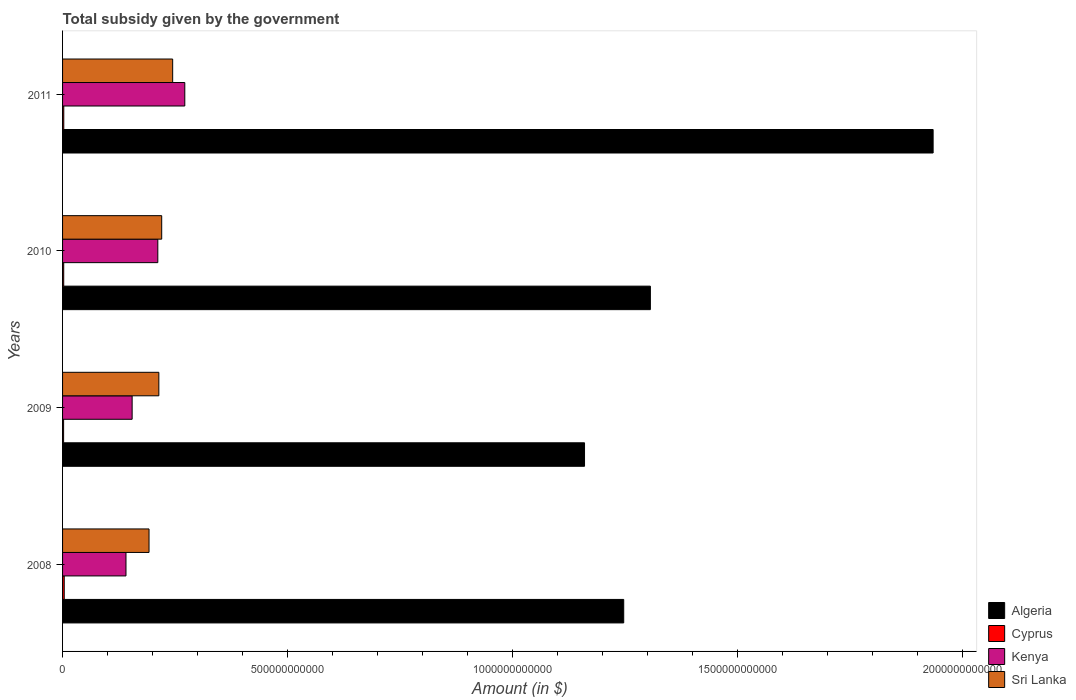Are the number of bars on each tick of the Y-axis equal?
Provide a succinct answer. Yes. How many bars are there on the 3rd tick from the top?
Your answer should be compact. 4. What is the label of the 2nd group of bars from the top?
Provide a short and direct response. 2010. In how many cases, is the number of bars for a given year not equal to the number of legend labels?
Your answer should be compact. 0. What is the total revenue collected by the government in Cyprus in 2008?
Your answer should be compact. 3.71e+09. Across all years, what is the maximum total revenue collected by the government in Algeria?
Offer a very short reply. 1.93e+12. Across all years, what is the minimum total revenue collected by the government in Sri Lanka?
Provide a succinct answer. 1.92e+11. In which year was the total revenue collected by the government in Sri Lanka maximum?
Offer a very short reply. 2011. In which year was the total revenue collected by the government in Algeria minimum?
Provide a succinct answer. 2009. What is the total total revenue collected by the government in Algeria in the graph?
Give a very brief answer. 5.65e+12. What is the difference between the total revenue collected by the government in Algeria in 2009 and that in 2010?
Give a very brief answer. -1.46e+11. What is the difference between the total revenue collected by the government in Kenya in 2009 and the total revenue collected by the government in Cyprus in 2011?
Your answer should be compact. 1.52e+11. What is the average total revenue collected by the government in Sri Lanka per year?
Keep it short and to the point. 2.18e+11. In the year 2008, what is the difference between the total revenue collected by the government in Sri Lanka and total revenue collected by the government in Cyprus?
Your answer should be very brief. 1.88e+11. What is the ratio of the total revenue collected by the government in Sri Lanka in 2010 to that in 2011?
Make the answer very short. 0.9. Is the total revenue collected by the government in Cyprus in 2010 less than that in 2011?
Offer a terse response. Yes. Is the difference between the total revenue collected by the government in Sri Lanka in 2009 and 2010 greater than the difference between the total revenue collected by the government in Cyprus in 2009 and 2010?
Make the answer very short. No. What is the difference between the highest and the second highest total revenue collected by the government in Algeria?
Provide a succinct answer. 6.28e+11. What is the difference between the highest and the lowest total revenue collected by the government in Sri Lanka?
Your answer should be very brief. 5.25e+1. In how many years, is the total revenue collected by the government in Sri Lanka greater than the average total revenue collected by the government in Sri Lanka taken over all years?
Give a very brief answer. 2. Is it the case that in every year, the sum of the total revenue collected by the government in Cyprus and total revenue collected by the government in Algeria is greater than the sum of total revenue collected by the government in Sri Lanka and total revenue collected by the government in Kenya?
Keep it short and to the point. Yes. What does the 3rd bar from the top in 2009 represents?
Provide a succinct answer. Cyprus. What does the 1st bar from the bottom in 2009 represents?
Your answer should be compact. Algeria. How many bars are there?
Keep it short and to the point. 16. Are all the bars in the graph horizontal?
Make the answer very short. Yes. What is the difference between two consecutive major ticks on the X-axis?
Make the answer very short. 5.00e+11. How many legend labels are there?
Provide a succinct answer. 4. What is the title of the graph?
Provide a succinct answer. Total subsidy given by the government. Does "St. Kitts and Nevis" appear as one of the legend labels in the graph?
Provide a short and direct response. No. What is the label or title of the X-axis?
Your answer should be very brief. Amount (in $). What is the label or title of the Y-axis?
Offer a very short reply. Years. What is the Amount (in $) in Algeria in 2008?
Offer a terse response. 1.25e+12. What is the Amount (in $) of Cyprus in 2008?
Provide a succinct answer. 3.71e+09. What is the Amount (in $) in Kenya in 2008?
Your answer should be very brief. 1.41e+11. What is the Amount (in $) of Sri Lanka in 2008?
Ensure brevity in your answer.  1.92e+11. What is the Amount (in $) in Algeria in 2009?
Ensure brevity in your answer.  1.16e+12. What is the Amount (in $) in Cyprus in 2009?
Provide a succinct answer. 2.31e+09. What is the Amount (in $) in Kenya in 2009?
Provide a succinct answer. 1.55e+11. What is the Amount (in $) in Sri Lanka in 2009?
Make the answer very short. 2.14e+11. What is the Amount (in $) of Algeria in 2010?
Offer a terse response. 1.31e+12. What is the Amount (in $) of Cyprus in 2010?
Offer a very short reply. 2.56e+09. What is the Amount (in $) of Kenya in 2010?
Your response must be concise. 2.12e+11. What is the Amount (in $) of Sri Lanka in 2010?
Provide a short and direct response. 2.20e+11. What is the Amount (in $) of Algeria in 2011?
Make the answer very short. 1.93e+12. What is the Amount (in $) of Cyprus in 2011?
Make the answer very short. 2.71e+09. What is the Amount (in $) of Kenya in 2011?
Keep it short and to the point. 2.72e+11. What is the Amount (in $) in Sri Lanka in 2011?
Ensure brevity in your answer.  2.45e+11. Across all years, what is the maximum Amount (in $) of Algeria?
Provide a short and direct response. 1.93e+12. Across all years, what is the maximum Amount (in $) of Cyprus?
Give a very brief answer. 3.71e+09. Across all years, what is the maximum Amount (in $) in Kenya?
Provide a short and direct response. 2.72e+11. Across all years, what is the maximum Amount (in $) in Sri Lanka?
Make the answer very short. 2.45e+11. Across all years, what is the minimum Amount (in $) of Algeria?
Offer a terse response. 1.16e+12. Across all years, what is the minimum Amount (in $) of Cyprus?
Your answer should be very brief. 2.31e+09. Across all years, what is the minimum Amount (in $) of Kenya?
Offer a terse response. 1.41e+11. Across all years, what is the minimum Amount (in $) in Sri Lanka?
Make the answer very short. 1.92e+11. What is the total Amount (in $) in Algeria in the graph?
Keep it short and to the point. 5.65e+12. What is the total Amount (in $) of Cyprus in the graph?
Provide a short and direct response. 1.13e+1. What is the total Amount (in $) of Kenya in the graph?
Make the answer very short. 7.79e+11. What is the total Amount (in $) of Sri Lanka in the graph?
Your response must be concise. 8.71e+11. What is the difference between the Amount (in $) of Algeria in 2008 and that in 2009?
Make the answer very short. 8.71e+1. What is the difference between the Amount (in $) in Cyprus in 2008 and that in 2009?
Provide a succinct answer. 1.40e+09. What is the difference between the Amount (in $) of Kenya in 2008 and that in 2009?
Provide a short and direct response. -1.37e+1. What is the difference between the Amount (in $) of Sri Lanka in 2008 and that in 2009?
Your response must be concise. -2.18e+1. What is the difference between the Amount (in $) in Algeria in 2008 and that in 2010?
Give a very brief answer. -5.92e+1. What is the difference between the Amount (in $) of Cyprus in 2008 and that in 2010?
Your response must be concise. 1.15e+09. What is the difference between the Amount (in $) of Kenya in 2008 and that in 2010?
Your answer should be compact. -7.07e+1. What is the difference between the Amount (in $) in Sri Lanka in 2008 and that in 2010?
Your answer should be very brief. -2.82e+1. What is the difference between the Amount (in $) in Algeria in 2008 and that in 2011?
Ensure brevity in your answer.  -6.88e+11. What is the difference between the Amount (in $) in Cyprus in 2008 and that in 2011?
Your answer should be compact. 9.95e+08. What is the difference between the Amount (in $) in Kenya in 2008 and that in 2011?
Give a very brief answer. -1.31e+11. What is the difference between the Amount (in $) in Sri Lanka in 2008 and that in 2011?
Offer a very short reply. -5.25e+1. What is the difference between the Amount (in $) in Algeria in 2009 and that in 2010?
Offer a very short reply. -1.46e+11. What is the difference between the Amount (in $) in Cyprus in 2009 and that in 2010?
Provide a succinct answer. -2.53e+08. What is the difference between the Amount (in $) of Kenya in 2009 and that in 2010?
Offer a terse response. -5.71e+1. What is the difference between the Amount (in $) of Sri Lanka in 2009 and that in 2010?
Ensure brevity in your answer.  -6.37e+09. What is the difference between the Amount (in $) in Algeria in 2009 and that in 2011?
Offer a very short reply. -7.75e+11. What is the difference between the Amount (in $) in Cyprus in 2009 and that in 2011?
Offer a very short reply. -4.07e+08. What is the difference between the Amount (in $) in Kenya in 2009 and that in 2011?
Your response must be concise. -1.17e+11. What is the difference between the Amount (in $) in Sri Lanka in 2009 and that in 2011?
Your response must be concise. -3.07e+1. What is the difference between the Amount (in $) in Algeria in 2010 and that in 2011?
Your answer should be compact. -6.28e+11. What is the difference between the Amount (in $) in Cyprus in 2010 and that in 2011?
Your answer should be very brief. -1.53e+08. What is the difference between the Amount (in $) of Kenya in 2010 and that in 2011?
Give a very brief answer. -6.00e+1. What is the difference between the Amount (in $) in Sri Lanka in 2010 and that in 2011?
Your answer should be compact. -2.44e+1. What is the difference between the Amount (in $) of Algeria in 2008 and the Amount (in $) of Cyprus in 2009?
Give a very brief answer. 1.24e+12. What is the difference between the Amount (in $) of Algeria in 2008 and the Amount (in $) of Kenya in 2009?
Provide a short and direct response. 1.09e+12. What is the difference between the Amount (in $) of Algeria in 2008 and the Amount (in $) of Sri Lanka in 2009?
Offer a terse response. 1.03e+12. What is the difference between the Amount (in $) in Cyprus in 2008 and the Amount (in $) in Kenya in 2009?
Your answer should be very brief. -1.51e+11. What is the difference between the Amount (in $) in Cyprus in 2008 and the Amount (in $) in Sri Lanka in 2009?
Provide a succinct answer. -2.10e+11. What is the difference between the Amount (in $) of Kenya in 2008 and the Amount (in $) of Sri Lanka in 2009?
Ensure brevity in your answer.  -7.30e+1. What is the difference between the Amount (in $) in Algeria in 2008 and the Amount (in $) in Cyprus in 2010?
Offer a terse response. 1.24e+12. What is the difference between the Amount (in $) of Algeria in 2008 and the Amount (in $) of Kenya in 2010?
Offer a terse response. 1.04e+12. What is the difference between the Amount (in $) of Algeria in 2008 and the Amount (in $) of Sri Lanka in 2010?
Your answer should be compact. 1.03e+12. What is the difference between the Amount (in $) of Cyprus in 2008 and the Amount (in $) of Kenya in 2010?
Offer a very short reply. -2.08e+11. What is the difference between the Amount (in $) of Cyprus in 2008 and the Amount (in $) of Sri Lanka in 2010?
Your answer should be compact. -2.17e+11. What is the difference between the Amount (in $) of Kenya in 2008 and the Amount (in $) of Sri Lanka in 2010?
Offer a very short reply. -7.94e+1. What is the difference between the Amount (in $) of Algeria in 2008 and the Amount (in $) of Cyprus in 2011?
Your response must be concise. 1.24e+12. What is the difference between the Amount (in $) in Algeria in 2008 and the Amount (in $) in Kenya in 2011?
Ensure brevity in your answer.  9.75e+11. What is the difference between the Amount (in $) of Algeria in 2008 and the Amount (in $) of Sri Lanka in 2011?
Provide a succinct answer. 1.00e+12. What is the difference between the Amount (in $) in Cyprus in 2008 and the Amount (in $) in Kenya in 2011?
Make the answer very short. -2.68e+11. What is the difference between the Amount (in $) in Cyprus in 2008 and the Amount (in $) in Sri Lanka in 2011?
Offer a very short reply. -2.41e+11. What is the difference between the Amount (in $) of Kenya in 2008 and the Amount (in $) of Sri Lanka in 2011?
Make the answer very short. -1.04e+11. What is the difference between the Amount (in $) in Algeria in 2009 and the Amount (in $) in Cyprus in 2010?
Provide a succinct answer. 1.16e+12. What is the difference between the Amount (in $) of Algeria in 2009 and the Amount (in $) of Kenya in 2010?
Provide a short and direct response. 9.48e+11. What is the difference between the Amount (in $) of Algeria in 2009 and the Amount (in $) of Sri Lanka in 2010?
Offer a terse response. 9.40e+11. What is the difference between the Amount (in $) of Cyprus in 2009 and the Amount (in $) of Kenya in 2010?
Keep it short and to the point. -2.09e+11. What is the difference between the Amount (in $) in Cyprus in 2009 and the Amount (in $) in Sri Lanka in 2010?
Make the answer very short. -2.18e+11. What is the difference between the Amount (in $) in Kenya in 2009 and the Amount (in $) in Sri Lanka in 2010?
Offer a very short reply. -6.57e+1. What is the difference between the Amount (in $) of Algeria in 2009 and the Amount (in $) of Cyprus in 2011?
Your response must be concise. 1.16e+12. What is the difference between the Amount (in $) of Algeria in 2009 and the Amount (in $) of Kenya in 2011?
Give a very brief answer. 8.88e+11. What is the difference between the Amount (in $) in Algeria in 2009 and the Amount (in $) in Sri Lanka in 2011?
Offer a very short reply. 9.15e+11. What is the difference between the Amount (in $) of Cyprus in 2009 and the Amount (in $) of Kenya in 2011?
Provide a short and direct response. -2.69e+11. What is the difference between the Amount (in $) of Cyprus in 2009 and the Amount (in $) of Sri Lanka in 2011?
Make the answer very short. -2.42e+11. What is the difference between the Amount (in $) in Kenya in 2009 and the Amount (in $) in Sri Lanka in 2011?
Provide a succinct answer. -9.01e+1. What is the difference between the Amount (in $) in Algeria in 2010 and the Amount (in $) in Cyprus in 2011?
Keep it short and to the point. 1.30e+12. What is the difference between the Amount (in $) of Algeria in 2010 and the Amount (in $) of Kenya in 2011?
Offer a terse response. 1.03e+12. What is the difference between the Amount (in $) in Algeria in 2010 and the Amount (in $) in Sri Lanka in 2011?
Your answer should be compact. 1.06e+12. What is the difference between the Amount (in $) of Cyprus in 2010 and the Amount (in $) of Kenya in 2011?
Provide a succinct answer. -2.69e+11. What is the difference between the Amount (in $) of Cyprus in 2010 and the Amount (in $) of Sri Lanka in 2011?
Your response must be concise. -2.42e+11. What is the difference between the Amount (in $) in Kenya in 2010 and the Amount (in $) in Sri Lanka in 2011?
Offer a terse response. -3.30e+1. What is the average Amount (in $) of Algeria per year?
Keep it short and to the point. 1.41e+12. What is the average Amount (in $) in Cyprus per year?
Give a very brief answer. 2.82e+09. What is the average Amount (in $) in Kenya per year?
Offer a terse response. 1.95e+11. What is the average Amount (in $) of Sri Lanka per year?
Your answer should be compact. 2.18e+11. In the year 2008, what is the difference between the Amount (in $) in Algeria and Amount (in $) in Cyprus?
Ensure brevity in your answer.  1.24e+12. In the year 2008, what is the difference between the Amount (in $) of Algeria and Amount (in $) of Kenya?
Give a very brief answer. 1.11e+12. In the year 2008, what is the difference between the Amount (in $) of Algeria and Amount (in $) of Sri Lanka?
Make the answer very short. 1.05e+12. In the year 2008, what is the difference between the Amount (in $) in Cyprus and Amount (in $) in Kenya?
Ensure brevity in your answer.  -1.37e+11. In the year 2008, what is the difference between the Amount (in $) in Cyprus and Amount (in $) in Sri Lanka?
Provide a short and direct response. -1.88e+11. In the year 2008, what is the difference between the Amount (in $) of Kenya and Amount (in $) of Sri Lanka?
Provide a succinct answer. -5.12e+1. In the year 2009, what is the difference between the Amount (in $) in Algeria and Amount (in $) in Cyprus?
Your response must be concise. 1.16e+12. In the year 2009, what is the difference between the Amount (in $) in Algeria and Amount (in $) in Kenya?
Ensure brevity in your answer.  1.01e+12. In the year 2009, what is the difference between the Amount (in $) in Algeria and Amount (in $) in Sri Lanka?
Provide a succinct answer. 9.46e+11. In the year 2009, what is the difference between the Amount (in $) in Cyprus and Amount (in $) in Kenya?
Make the answer very short. -1.52e+11. In the year 2009, what is the difference between the Amount (in $) in Cyprus and Amount (in $) in Sri Lanka?
Your answer should be compact. -2.12e+11. In the year 2009, what is the difference between the Amount (in $) of Kenya and Amount (in $) of Sri Lanka?
Ensure brevity in your answer.  -5.93e+1. In the year 2010, what is the difference between the Amount (in $) in Algeria and Amount (in $) in Cyprus?
Provide a succinct answer. 1.30e+12. In the year 2010, what is the difference between the Amount (in $) in Algeria and Amount (in $) in Kenya?
Offer a terse response. 1.09e+12. In the year 2010, what is the difference between the Amount (in $) in Algeria and Amount (in $) in Sri Lanka?
Your response must be concise. 1.09e+12. In the year 2010, what is the difference between the Amount (in $) of Cyprus and Amount (in $) of Kenya?
Ensure brevity in your answer.  -2.09e+11. In the year 2010, what is the difference between the Amount (in $) in Cyprus and Amount (in $) in Sri Lanka?
Make the answer very short. -2.18e+11. In the year 2010, what is the difference between the Amount (in $) of Kenya and Amount (in $) of Sri Lanka?
Offer a very short reply. -8.65e+09. In the year 2011, what is the difference between the Amount (in $) of Algeria and Amount (in $) of Cyprus?
Keep it short and to the point. 1.93e+12. In the year 2011, what is the difference between the Amount (in $) in Algeria and Amount (in $) in Kenya?
Offer a terse response. 1.66e+12. In the year 2011, what is the difference between the Amount (in $) in Algeria and Amount (in $) in Sri Lanka?
Keep it short and to the point. 1.69e+12. In the year 2011, what is the difference between the Amount (in $) in Cyprus and Amount (in $) in Kenya?
Your answer should be very brief. -2.69e+11. In the year 2011, what is the difference between the Amount (in $) in Cyprus and Amount (in $) in Sri Lanka?
Your answer should be compact. -2.42e+11. In the year 2011, what is the difference between the Amount (in $) of Kenya and Amount (in $) of Sri Lanka?
Make the answer very short. 2.70e+1. What is the ratio of the Amount (in $) of Algeria in 2008 to that in 2009?
Offer a very short reply. 1.08. What is the ratio of the Amount (in $) of Cyprus in 2008 to that in 2009?
Give a very brief answer. 1.61. What is the ratio of the Amount (in $) of Kenya in 2008 to that in 2009?
Your response must be concise. 0.91. What is the ratio of the Amount (in $) in Sri Lanka in 2008 to that in 2009?
Your response must be concise. 0.9. What is the ratio of the Amount (in $) of Algeria in 2008 to that in 2010?
Offer a terse response. 0.95. What is the ratio of the Amount (in $) of Cyprus in 2008 to that in 2010?
Provide a short and direct response. 1.45. What is the ratio of the Amount (in $) in Kenya in 2008 to that in 2010?
Give a very brief answer. 0.67. What is the ratio of the Amount (in $) in Sri Lanka in 2008 to that in 2010?
Give a very brief answer. 0.87. What is the ratio of the Amount (in $) of Algeria in 2008 to that in 2011?
Keep it short and to the point. 0.64. What is the ratio of the Amount (in $) in Cyprus in 2008 to that in 2011?
Offer a terse response. 1.37. What is the ratio of the Amount (in $) in Kenya in 2008 to that in 2011?
Provide a short and direct response. 0.52. What is the ratio of the Amount (in $) of Sri Lanka in 2008 to that in 2011?
Give a very brief answer. 0.79. What is the ratio of the Amount (in $) of Algeria in 2009 to that in 2010?
Offer a very short reply. 0.89. What is the ratio of the Amount (in $) of Cyprus in 2009 to that in 2010?
Your answer should be compact. 0.9. What is the ratio of the Amount (in $) in Kenya in 2009 to that in 2010?
Make the answer very short. 0.73. What is the ratio of the Amount (in $) of Sri Lanka in 2009 to that in 2010?
Make the answer very short. 0.97. What is the ratio of the Amount (in $) of Algeria in 2009 to that in 2011?
Offer a terse response. 0.6. What is the ratio of the Amount (in $) of Cyprus in 2009 to that in 2011?
Your answer should be very brief. 0.85. What is the ratio of the Amount (in $) of Kenya in 2009 to that in 2011?
Your answer should be very brief. 0.57. What is the ratio of the Amount (in $) in Sri Lanka in 2009 to that in 2011?
Make the answer very short. 0.87. What is the ratio of the Amount (in $) in Algeria in 2010 to that in 2011?
Provide a succinct answer. 0.68. What is the ratio of the Amount (in $) in Cyprus in 2010 to that in 2011?
Ensure brevity in your answer.  0.94. What is the ratio of the Amount (in $) in Kenya in 2010 to that in 2011?
Make the answer very short. 0.78. What is the ratio of the Amount (in $) in Sri Lanka in 2010 to that in 2011?
Ensure brevity in your answer.  0.9. What is the difference between the highest and the second highest Amount (in $) of Algeria?
Offer a terse response. 6.28e+11. What is the difference between the highest and the second highest Amount (in $) in Cyprus?
Offer a very short reply. 9.95e+08. What is the difference between the highest and the second highest Amount (in $) of Kenya?
Provide a succinct answer. 6.00e+1. What is the difference between the highest and the second highest Amount (in $) in Sri Lanka?
Provide a short and direct response. 2.44e+1. What is the difference between the highest and the lowest Amount (in $) in Algeria?
Ensure brevity in your answer.  7.75e+11. What is the difference between the highest and the lowest Amount (in $) in Cyprus?
Make the answer very short. 1.40e+09. What is the difference between the highest and the lowest Amount (in $) of Kenya?
Give a very brief answer. 1.31e+11. What is the difference between the highest and the lowest Amount (in $) of Sri Lanka?
Offer a very short reply. 5.25e+1. 